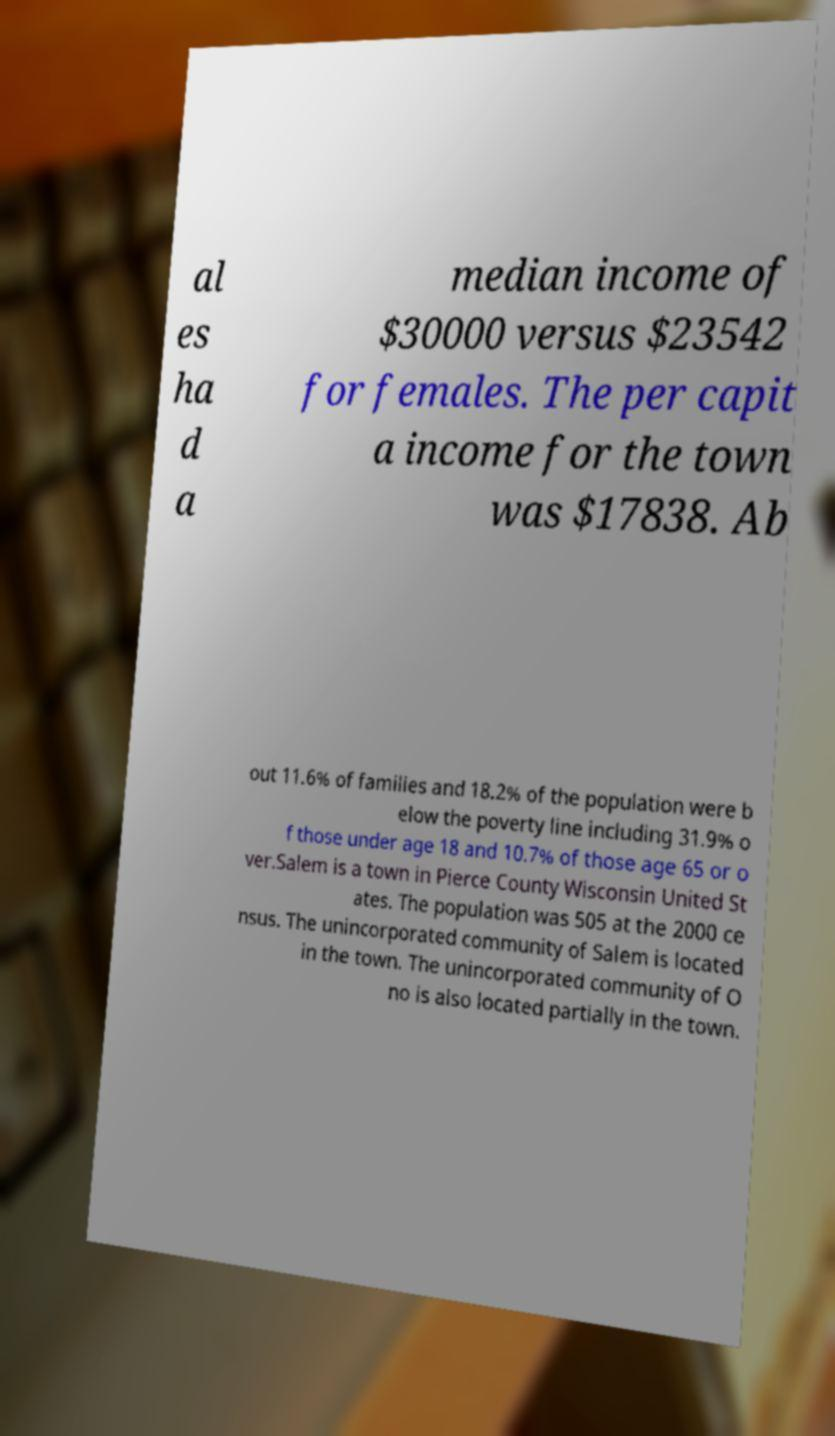Please read and relay the text visible in this image. What does it say? al es ha d a median income of $30000 versus $23542 for females. The per capit a income for the town was $17838. Ab out 11.6% of families and 18.2% of the population were b elow the poverty line including 31.9% o f those under age 18 and 10.7% of those age 65 or o ver.Salem is a town in Pierce County Wisconsin United St ates. The population was 505 at the 2000 ce nsus. The unincorporated community of Salem is located in the town. The unincorporated community of O no is also located partially in the town. 